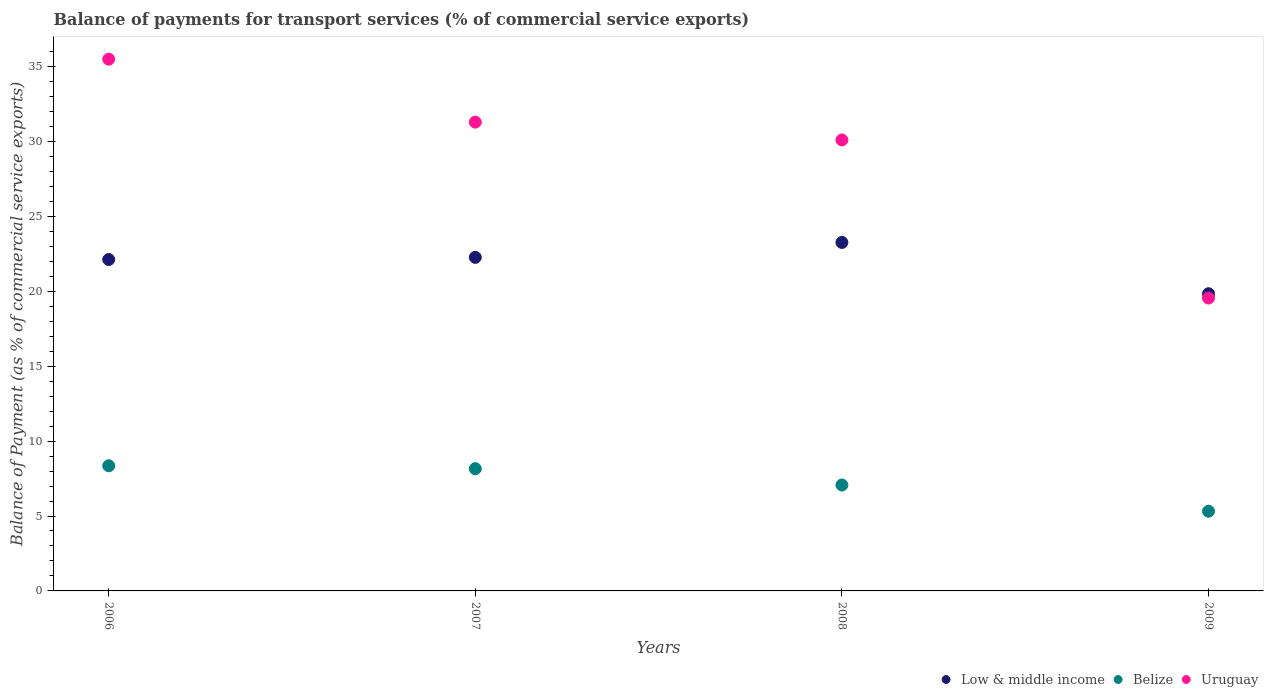Is the number of dotlines equal to the number of legend labels?
Keep it short and to the point. Yes. What is the balance of payments for transport services in Belize in 2006?
Offer a terse response. 8.35. Across all years, what is the maximum balance of payments for transport services in Belize?
Make the answer very short. 8.35. Across all years, what is the minimum balance of payments for transport services in Low & middle income?
Offer a terse response. 19.84. In which year was the balance of payments for transport services in Belize maximum?
Your response must be concise. 2006. What is the total balance of payments for transport services in Low & middle income in the graph?
Give a very brief answer. 87.48. What is the difference between the balance of payments for transport services in Low & middle income in 2006 and that in 2008?
Make the answer very short. -1.14. What is the difference between the balance of payments for transport services in Uruguay in 2008 and the balance of payments for transport services in Low & middle income in 2009?
Provide a short and direct response. 10.26. What is the average balance of payments for transport services in Low & middle income per year?
Provide a succinct answer. 21.87. In the year 2009, what is the difference between the balance of payments for transport services in Belize and balance of payments for transport services in Uruguay?
Your answer should be very brief. -14.23. In how many years, is the balance of payments for transport services in Uruguay greater than 1 %?
Keep it short and to the point. 4. What is the ratio of the balance of payments for transport services in Belize in 2006 to that in 2008?
Your response must be concise. 1.18. Is the balance of payments for transport services in Low & middle income in 2007 less than that in 2008?
Your answer should be very brief. Yes. What is the difference between the highest and the second highest balance of payments for transport services in Low & middle income?
Make the answer very short. 1. What is the difference between the highest and the lowest balance of payments for transport services in Belize?
Your answer should be very brief. 3.03. In how many years, is the balance of payments for transport services in Uruguay greater than the average balance of payments for transport services in Uruguay taken over all years?
Give a very brief answer. 3. Is the sum of the balance of payments for transport services in Belize in 2007 and 2008 greater than the maximum balance of payments for transport services in Uruguay across all years?
Keep it short and to the point. No. Does the balance of payments for transport services in Uruguay monotonically increase over the years?
Give a very brief answer. No. Is the balance of payments for transport services in Belize strictly greater than the balance of payments for transport services in Uruguay over the years?
Keep it short and to the point. No. Is the balance of payments for transport services in Belize strictly less than the balance of payments for transport services in Uruguay over the years?
Offer a very short reply. Yes. How many dotlines are there?
Make the answer very short. 3. Are the values on the major ticks of Y-axis written in scientific E-notation?
Your answer should be compact. No. Does the graph contain any zero values?
Offer a terse response. No. Where does the legend appear in the graph?
Ensure brevity in your answer.  Bottom right. How many legend labels are there?
Your answer should be very brief. 3. How are the legend labels stacked?
Your response must be concise. Horizontal. What is the title of the graph?
Ensure brevity in your answer.  Balance of payments for transport services (% of commercial service exports). Does "Trinidad and Tobago" appear as one of the legend labels in the graph?
Make the answer very short. No. What is the label or title of the X-axis?
Keep it short and to the point. Years. What is the label or title of the Y-axis?
Offer a very short reply. Balance of Payment (as % of commercial service exports). What is the Balance of Payment (as % of commercial service exports) in Low & middle income in 2006?
Offer a very short reply. 22.12. What is the Balance of Payment (as % of commercial service exports) in Belize in 2006?
Provide a succinct answer. 8.35. What is the Balance of Payment (as % of commercial service exports) in Uruguay in 2006?
Your answer should be very brief. 35.49. What is the Balance of Payment (as % of commercial service exports) in Low & middle income in 2007?
Your answer should be compact. 22.26. What is the Balance of Payment (as % of commercial service exports) in Belize in 2007?
Offer a very short reply. 8.16. What is the Balance of Payment (as % of commercial service exports) of Uruguay in 2007?
Keep it short and to the point. 31.29. What is the Balance of Payment (as % of commercial service exports) of Low & middle income in 2008?
Keep it short and to the point. 23.26. What is the Balance of Payment (as % of commercial service exports) in Belize in 2008?
Ensure brevity in your answer.  7.07. What is the Balance of Payment (as % of commercial service exports) of Uruguay in 2008?
Ensure brevity in your answer.  30.1. What is the Balance of Payment (as % of commercial service exports) of Low & middle income in 2009?
Keep it short and to the point. 19.84. What is the Balance of Payment (as % of commercial service exports) in Belize in 2009?
Give a very brief answer. 5.32. What is the Balance of Payment (as % of commercial service exports) in Uruguay in 2009?
Provide a short and direct response. 19.55. Across all years, what is the maximum Balance of Payment (as % of commercial service exports) in Low & middle income?
Your answer should be very brief. 23.26. Across all years, what is the maximum Balance of Payment (as % of commercial service exports) of Belize?
Keep it short and to the point. 8.35. Across all years, what is the maximum Balance of Payment (as % of commercial service exports) of Uruguay?
Make the answer very short. 35.49. Across all years, what is the minimum Balance of Payment (as % of commercial service exports) in Low & middle income?
Your response must be concise. 19.84. Across all years, what is the minimum Balance of Payment (as % of commercial service exports) in Belize?
Your answer should be very brief. 5.32. Across all years, what is the minimum Balance of Payment (as % of commercial service exports) of Uruguay?
Make the answer very short. 19.55. What is the total Balance of Payment (as % of commercial service exports) in Low & middle income in the graph?
Your response must be concise. 87.48. What is the total Balance of Payment (as % of commercial service exports) in Belize in the graph?
Provide a succinct answer. 28.9. What is the total Balance of Payment (as % of commercial service exports) in Uruguay in the graph?
Give a very brief answer. 116.42. What is the difference between the Balance of Payment (as % of commercial service exports) in Low & middle income in 2006 and that in 2007?
Ensure brevity in your answer.  -0.14. What is the difference between the Balance of Payment (as % of commercial service exports) of Belize in 2006 and that in 2007?
Provide a short and direct response. 0.19. What is the difference between the Balance of Payment (as % of commercial service exports) of Uruguay in 2006 and that in 2007?
Make the answer very short. 4.2. What is the difference between the Balance of Payment (as % of commercial service exports) in Low & middle income in 2006 and that in 2008?
Provide a succinct answer. -1.14. What is the difference between the Balance of Payment (as % of commercial service exports) of Belize in 2006 and that in 2008?
Offer a very short reply. 1.28. What is the difference between the Balance of Payment (as % of commercial service exports) in Uruguay in 2006 and that in 2008?
Give a very brief answer. 5.39. What is the difference between the Balance of Payment (as % of commercial service exports) in Low & middle income in 2006 and that in 2009?
Make the answer very short. 2.28. What is the difference between the Balance of Payment (as % of commercial service exports) of Belize in 2006 and that in 2009?
Ensure brevity in your answer.  3.03. What is the difference between the Balance of Payment (as % of commercial service exports) in Uruguay in 2006 and that in 2009?
Provide a succinct answer. 15.94. What is the difference between the Balance of Payment (as % of commercial service exports) of Low & middle income in 2007 and that in 2008?
Keep it short and to the point. -1. What is the difference between the Balance of Payment (as % of commercial service exports) of Belize in 2007 and that in 2008?
Offer a terse response. 1.09. What is the difference between the Balance of Payment (as % of commercial service exports) in Uruguay in 2007 and that in 2008?
Provide a short and direct response. 1.19. What is the difference between the Balance of Payment (as % of commercial service exports) in Low & middle income in 2007 and that in 2009?
Offer a terse response. 2.43. What is the difference between the Balance of Payment (as % of commercial service exports) of Belize in 2007 and that in 2009?
Offer a very short reply. 2.84. What is the difference between the Balance of Payment (as % of commercial service exports) of Uruguay in 2007 and that in 2009?
Provide a succinct answer. 11.74. What is the difference between the Balance of Payment (as % of commercial service exports) in Low & middle income in 2008 and that in 2009?
Make the answer very short. 3.42. What is the difference between the Balance of Payment (as % of commercial service exports) of Belize in 2008 and that in 2009?
Ensure brevity in your answer.  1.75. What is the difference between the Balance of Payment (as % of commercial service exports) in Uruguay in 2008 and that in 2009?
Your answer should be very brief. 10.55. What is the difference between the Balance of Payment (as % of commercial service exports) of Low & middle income in 2006 and the Balance of Payment (as % of commercial service exports) of Belize in 2007?
Give a very brief answer. 13.96. What is the difference between the Balance of Payment (as % of commercial service exports) of Low & middle income in 2006 and the Balance of Payment (as % of commercial service exports) of Uruguay in 2007?
Offer a terse response. -9.17. What is the difference between the Balance of Payment (as % of commercial service exports) of Belize in 2006 and the Balance of Payment (as % of commercial service exports) of Uruguay in 2007?
Offer a very short reply. -22.93. What is the difference between the Balance of Payment (as % of commercial service exports) in Low & middle income in 2006 and the Balance of Payment (as % of commercial service exports) in Belize in 2008?
Your answer should be very brief. 15.05. What is the difference between the Balance of Payment (as % of commercial service exports) of Low & middle income in 2006 and the Balance of Payment (as % of commercial service exports) of Uruguay in 2008?
Provide a short and direct response. -7.98. What is the difference between the Balance of Payment (as % of commercial service exports) of Belize in 2006 and the Balance of Payment (as % of commercial service exports) of Uruguay in 2008?
Offer a terse response. -21.75. What is the difference between the Balance of Payment (as % of commercial service exports) in Low & middle income in 2006 and the Balance of Payment (as % of commercial service exports) in Belize in 2009?
Provide a short and direct response. 16.8. What is the difference between the Balance of Payment (as % of commercial service exports) in Low & middle income in 2006 and the Balance of Payment (as % of commercial service exports) in Uruguay in 2009?
Your answer should be very brief. 2.57. What is the difference between the Balance of Payment (as % of commercial service exports) in Belize in 2006 and the Balance of Payment (as % of commercial service exports) in Uruguay in 2009?
Keep it short and to the point. -11.19. What is the difference between the Balance of Payment (as % of commercial service exports) of Low & middle income in 2007 and the Balance of Payment (as % of commercial service exports) of Belize in 2008?
Your answer should be compact. 15.19. What is the difference between the Balance of Payment (as % of commercial service exports) of Low & middle income in 2007 and the Balance of Payment (as % of commercial service exports) of Uruguay in 2008?
Your answer should be compact. -7.84. What is the difference between the Balance of Payment (as % of commercial service exports) of Belize in 2007 and the Balance of Payment (as % of commercial service exports) of Uruguay in 2008?
Your response must be concise. -21.94. What is the difference between the Balance of Payment (as % of commercial service exports) in Low & middle income in 2007 and the Balance of Payment (as % of commercial service exports) in Belize in 2009?
Your answer should be compact. 16.94. What is the difference between the Balance of Payment (as % of commercial service exports) in Low & middle income in 2007 and the Balance of Payment (as % of commercial service exports) in Uruguay in 2009?
Ensure brevity in your answer.  2.72. What is the difference between the Balance of Payment (as % of commercial service exports) of Belize in 2007 and the Balance of Payment (as % of commercial service exports) of Uruguay in 2009?
Your response must be concise. -11.39. What is the difference between the Balance of Payment (as % of commercial service exports) of Low & middle income in 2008 and the Balance of Payment (as % of commercial service exports) of Belize in 2009?
Ensure brevity in your answer.  17.94. What is the difference between the Balance of Payment (as % of commercial service exports) in Low & middle income in 2008 and the Balance of Payment (as % of commercial service exports) in Uruguay in 2009?
Offer a terse response. 3.71. What is the difference between the Balance of Payment (as % of commercial service exports) of Belize in 2008 and the Balance of Payment (as % of commercial service exports) of Uruguay in 2009?
Offer a very short reply. -12.48. What is the average Balance of Payment (as % of commercial service exports) in Low & middle income per year?
Offer a very short reply. 21.87. What is the average Balance of Payment (as % of commercial service exports) of Belize per year?
Give a very brief answer. 7.22. What is the average Balance of Payment (as % of commercial service exports) of Uruguay per year?
Your answer should be compact. 29.11. In the year 2006, what is the difference between the Balance of Payment (as % of commercial service exports) of Low & middle income and Balance of Payment (as % of commercial service exports) of Belize?
Provide a short and direct response. 13.77. In the year 2006, what is the difference between the Balance of Payment (as % of commercial service exports) in Low & middle income and Balance of Payment (as % of commercial service exports) in Uruguay?
Keep it short and to the point. -13.37. In the year 2006, what is the difference between the Balance of Payment (as % of commercial service exports) in Belize and Balance of Payment (as % of commercial service exports) in Uruguay?
Keep it short and to the point. -27.14. In the year 2007, what is the difference between the Balance of Payment (as % of commercial service exports) of Low & middle income and Balance of Payment (as % of commercial service exports) of Belize?
Give a very brief answer. 14.1. In the year 2007, what is the difference between the Balance of Payment (as % of commercial service exports) in Low & middle income and Balance of Payment (as % of commercial service exports) in Uruguay?
Offer a terse response. -9.02. In the year 2007, what is the difference between the Balance of Payment (as % of commercial service exports) in Belize and Balance of Payment (as % of commercial service exports) in Uruguay?
Keep it short and to the point. -23.13. In the year 2008, what is the difference between the Balance of Payment (as % of commercial service exports) of Low & middle income and Balance of Payment (as % of commercial service exports) of Belize?
Your answer should be very brief. 16.19. In the year 2008, what is the difference between the Balance of Payment (as % of commercial service exports) in Low & middle income and Balance of Payment (as % of commercial service exports) in Uruguay?
Your answer should be very brief. -6.84. In the year 2008, what is the difference between the Balance of Payment (as % of commercial service exports) in Belize and Balance of Payment (as % of commercial service exports) in Uruguay?
Your answer should be compact. -23.03. In the year 2009, what is the difference between the Balance of Payment (as % of commercial service exports) in Low & middle income and Balance of Payment (as % of commercial service exports) in Belize?
Keep it short and to the point. 14.52. In the year 2009, what is the difference between the Balance of Payment (as % of commercial service exports) of Low & middle income and Balance of Payment (as % of commercial service exports) of Uruguay?
Make the answer very short. 0.29. In the year 2009, what is the difference between the Balance of Payment (as % of commercial service exports) in Belize and Balance of Payment (as % of commercial service exports) in Uruguay?
Provide a short and direct response. -14.23. What is the ratio of the Balance of Payment (as % of commercial service exports) in Low & middle income in 2006 to that in 2007?
Your answer should be compact. 0.99. What is the ratio of the Balance of Payment (as % of commercial service exports) of Belize in 2006 to that in 2007?
Your answer should be compact. 1.02. What is the ratio of the Balance of Payment (as % of commercial service exports) of Uruguay in 2006 to that in 2007?
Offer a terse response. 1.13. What is the ratio of the Balance of Payment (as % of commercial service exports) of Low & middle income in 2006 to that in 2008?
Make the answer very short. 0.95. What is the ratio of the Balance of Payment (as % of commercial service exports) of Belize in 2006 to that in 2008?
Offer a terse response. 1.18. What is the ratio of the Balance of Payment (as % of commercial service exports) of Uruguay in 2006 to that in 2008?
Give a very brief answer. 1.18. What is the ratio of the Balance of Payment (as % of commercial service exports) of Low & middle income in 2006 to that in 2009?
Ensure brevity in your answer.  1.11. What is the ratio of the Balance of Payment (as % of commercial service exports) of Belize in 2006 to that in 2009?
Your answer should be very brief. 1.57. What is the ratio of the Balance of Payment (as % of commercial service exports) of Uruguay in 2006 to that in 2009?
Give a very brief answer. 1.82. What is the ratio of the Balance of Payment (as % of commercial service exports) in Low & middle income in 2007 to that in 2008?
Make the answer very short. 0.96. What is the ratio of the Balance of Payment (as % of commercial service exports) in Belize in 2007 to that in 2008?
Ensure brevity in your answer.  1.15. What is the ratio of the Balance of Payment (as % of commercial service exports) of Uruguay in 2007 to that in 2008?
Provide a succinct answer. 1.04. What is the ratio of the Balance of Payment (as % of commercial service exports) in Low & middle income in 2007 to that in 2009?
Your answer should be very brief. 1.12. What is the ratio of the Balance of Payment (as % of commercial service exports) in Belize in 2007 to that in 2009?
Keep it short and to the point. 1.53. What is the ratio of the Balance of Payment (as % of commercial service exports) of Uruguay in 2007 to that in 2009?
Make the answer very short. 1.6. What is the ratio of the Balance of Payment (as % of commercial service exports) in Low & middle income in 2008 to that in 2009?
Provide a succinct answer. 1.17. What is the ratio of the Balance of Payment (as % of commercial service exports) in Belize in 2008 to that in 2009?
Offer a very short reply. 1.33. What is the ratio of the Balance of Payment (as % of commercial service exports) of Uruguay in 2008 to that in 2009?
Provide a short and direct response. 1.54. What is the difference between the highest and the second highest Balance of Payment (as % of commercial service exports) of Low & middle income?
Keep it short and to the point. 1. What is the difference between the highest and the second highest Balance of Payment (as % of commercial service exports) of Belize?
Offer a very short reply. 0.19. What is the difference between the highest and the second highest Balance of Payment (as % of commercial service exports) of Uruguay?
Your answer should be very brief. 4.2. What is the difference between the highest and the lowest Balance of Payment (as % of commercial service exports) in Low & middle income?
Provide a short and direct response. 3.42. What is the difference between the highest and the lowest Balance of Payment (as % of commercial service exports) in Belize?
Offer a terse response. 3.03. What is the difference between the highest and the lowest Balance of Payment (as % of commercial service exports) in Uruguay?
Ensure brevity in your answer.  15.94. 